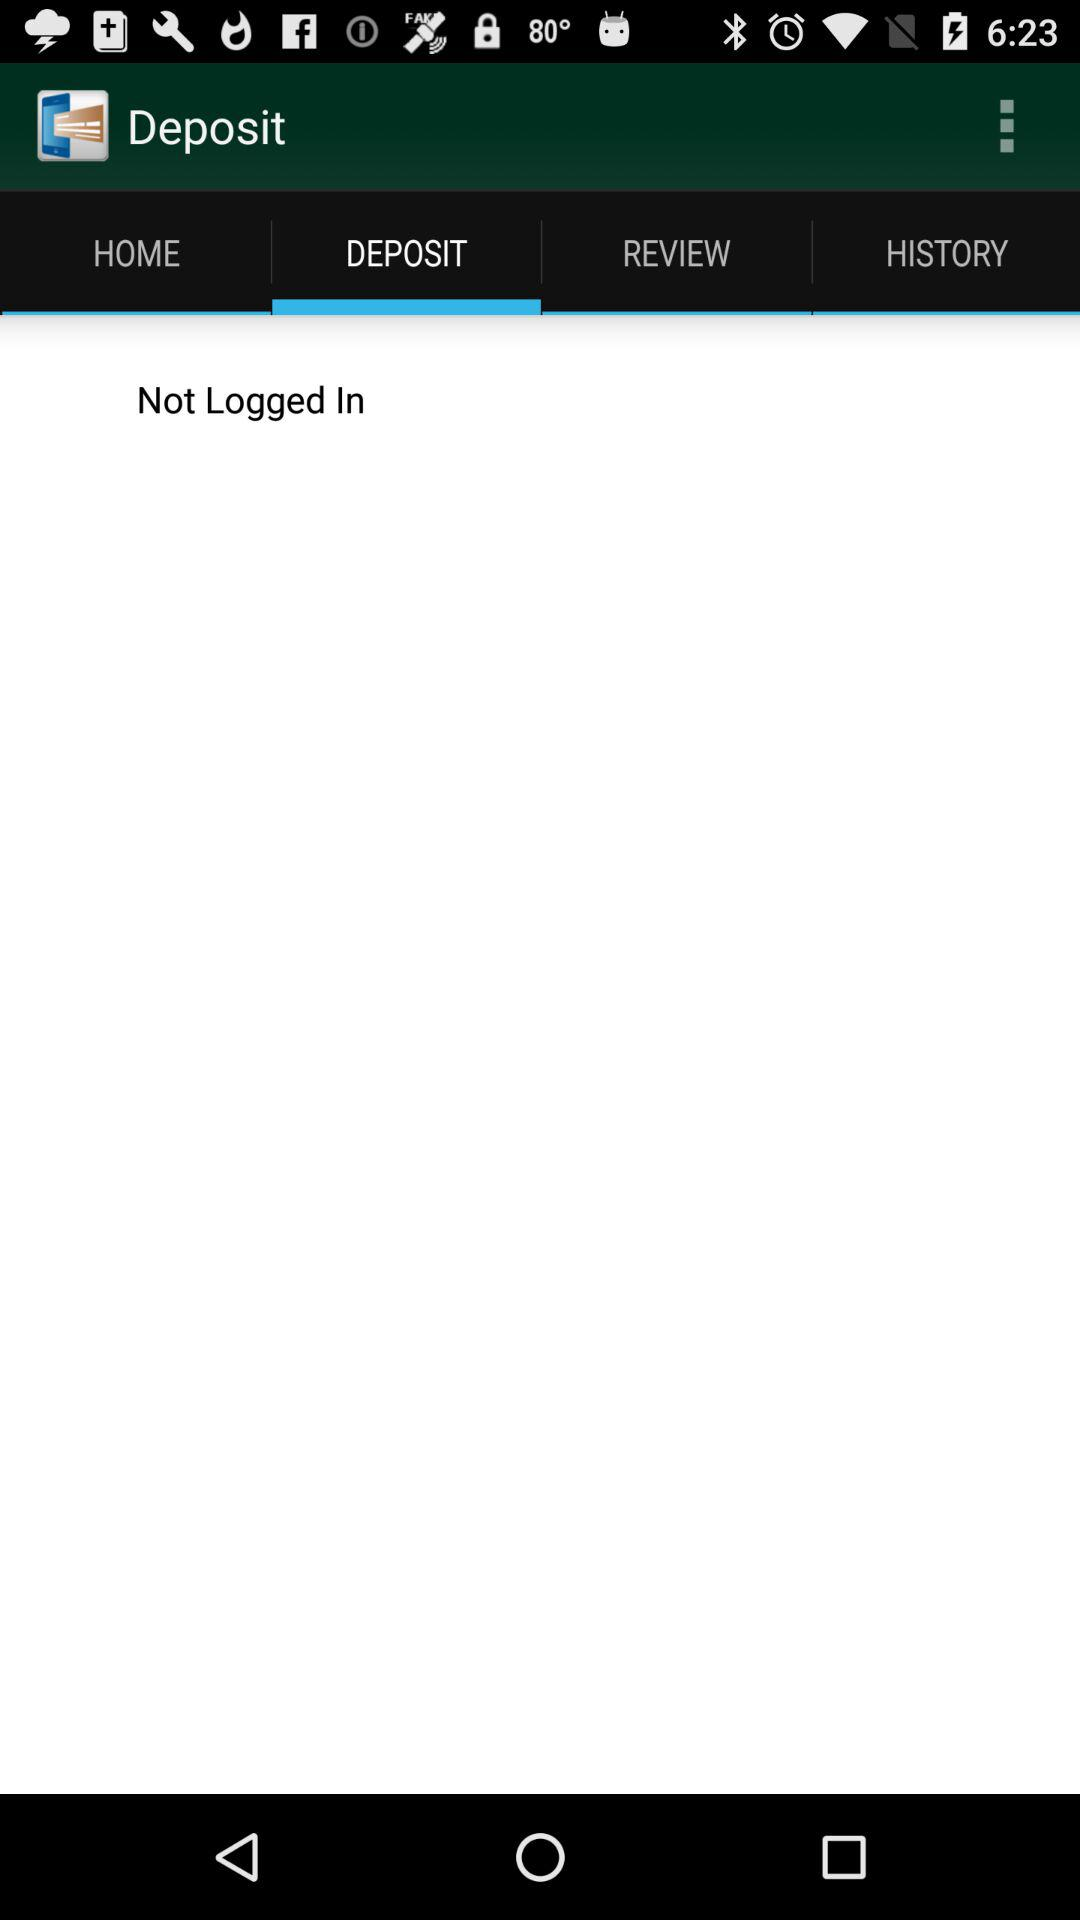Is the user logged in? The user is not logged in. 